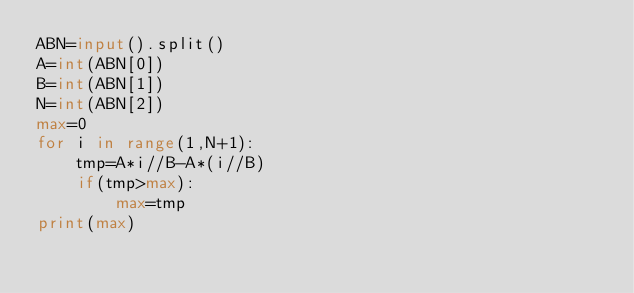<code> <loc_0><loc_0><loc_500><loc_500><_Python_>ABN=input().split()
A=int(ABN[0])
B=int(ABN[1])
N=int(ABN[2])
max=0
for i in range(1,N+1):
    tmp=A*i//B-A*(i//B)
    if(tmp>max):
        max=tmp
print(max)
</code> 